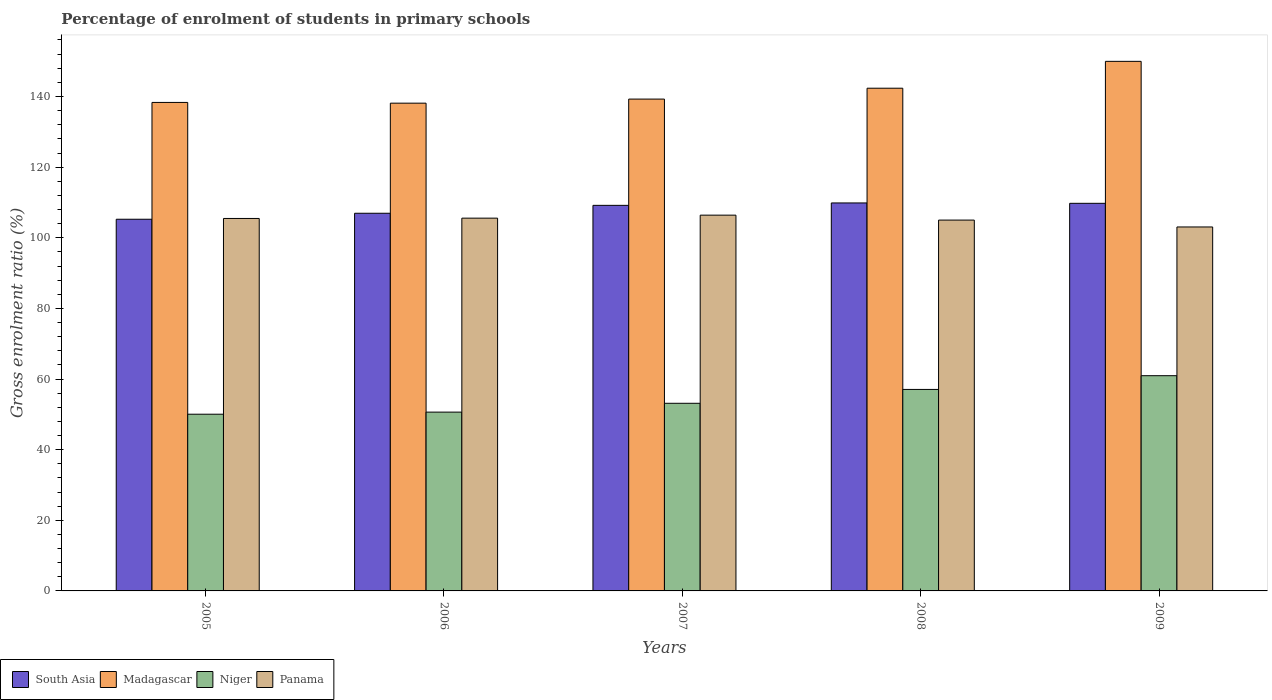How many different coloured bars are there?
Keep it short and to the point. 4. How many groups of bars are there?
Make the answer very short. 5. Are the number of bars per tick equal to the number of legend labels?
Offer a terse response. Yes. How many bars are there on the 5th tick from the left?
Offer a very short reply. 4. How many bars are there on the 2nd tick from the right?
Provide a short and direct response. 4. What is the label of the 2nd group of bars from the left?
Your response must be concise. 2006. In how many cases, is the number of bars for a given year not equal to the number of legend labels?
Keep it short and to the point. 0. What is the percentage of students enrolled in primary schools in Madagascar in 2005?
Provide a short and direct response. 138.32. Across all years, what is the maximum percentage of students enrolled in primary schools in Niger?
Your answer should be very brief. 60.94. Across all years, what is the minimum percentage of students enrolled in primary schools in South Asia?
Your answer should be compact. 105.25. In which year was the percentage of students enrolled in primary schools in Panama maximum?
Offer a very short reply. 2007. In which year was the percentage of students enrolled in primary schools in Niger minimum?
Provide a succinct answer. 2005. What is the total percentage of students enrolled in primary schools in Niger in the graph?
Offer a terse response. 271.79. What is the difference between the percentage of students enrolled in primary schools in South Asia in 2006 and that in 2008?
Provide a short and direct response. -2.92. What is the difference between the percentage of students enrolled in primary schools in Niger in 2007 and the percentage of students enrolled in primary schools in Panama in 2009?
Your response must be concise. -49.93. What is the average percentage of students enrolled in primary schools in Panama per year?
Offer a very short reply. 105.1. In the year 2005, what is the difference between the percentage of students enrolled in primary schools in Niger and percentage of students enrolled in primary schools in Panama?
Give a very brief answer. -55.43. What is the ratio of the percentage of students enrolled in primary schools in Madagascar in 2006 to that in 2008?
Offer a very short reply. 0.97. What is the difference between the highest and the second highest percentage of students enrolled in primary schools in Madagascar?
Your answer should be very brief. 7.61. What is the difference between the highest and the lowest percentage of students enrolled in primary schools in South Asia?
Offer a terse response. 4.61. In how many years, is the percentage of students enrolled in primary schools in Madagascar greater than the average percentage of students enrolled in primary schools in Madagascar taken over all years?
Offer a terse response. 2. What does the 4th bar from the left in 2007 represents?
Your answer should be compact. Panama. What does the 1st bar from the right in 2005 represents?
Offer a very short reply. Panama. Is it the case that in every year, the sum of the percentage of students enrolled in primary schools in Niger and percentage of students enrolled in primary schools in South Asia is greater than the percentage of students enrolled in primary schools in Madagascar?
Offer a very short reply. Yes. How many bars are there?
Ensure brevity in your answer.  20. What is the difference between two consecutive major ticks on the Y-axis?
Your answer should be very brief. 20. Where does the legend appear in the graph?
Offer a very short reply. Bottom left. How are the legend labels stacked?
Your response must be concise. Horizontal. What is the title of the graph?
Provide a short and direct response. Percentage of enrolment of students in primary schools. What is the label or title of the Y-axis?
Offer a terse response. Gross enrolment ratio (%). What is the Gross enrolment ratio (%) in South Asia in 2005?
Ensure brevity in your answer.  105.25. What is the Gross enrolment ratio (%) in Madagascar in 2005?
Provide a short and direct response. 138.32. What is the Gross enrolment ratio (%) of Niger in 2005?
Make the answer very short. 50.04. What is the Gross enrolment ratio (%) of Panama in 2005?
Your answer should be compact. 105.47. What is the Gross enrolment ratio (%) of South Asia in 2006?
Your answer should be compact. 106.94. What is the Gross enrolment ratio (%) in Madagascar in 2006?
Your response must be concise. 138.11. What is the Gross enrolment ratio (%) in Niger in 2006?
Offer a very short reply. 50.63. What is the Gross enrolment ratio (%) of Panama in 2006?
Your response must be concise. 105.55. What is the Gross enrolment ratio (%) in South Asia in 2007?
Give a very brief answer. 109.18. What is the Gross enrolment ratio (%) of Madagascar in 2007?
Provide a short and direct response. 139.27. What is the Gross enrolment ratio (%) in Niger in 2007?
Give a very brief answer. 53.13. What is the Gross enrolment ratio (%) in Panama in 2007?
Keep it short and to the point. 106.4. What is the Gross enrolment ratio (%) of South Asia in 2008?
Provide a succinct answer. 109.86. What is the Gross enrolment ratio (%) in Madagascar in 2008?
Keep it short and to the point. 142.35. What is the Gross enrolment ratio (%) of Niger in 2008?
Ensure brevity in your answer.  57.05. What is the Gross enrolment ratio (%) of Panama in 2008?
Ensure brevity in your answer.  105.01. What is the Gross enrolment ratio (%) in South Asia in 2009?
Your answer should be very brief. 109.75. What is the Gross enrolment ratio (%) in Madagascar in 2009?
Your answer should be very brief. 149.95. What is the Gross enrolment ratio (%) of Niger in 2009?
Offer a terse response. 60.94. What is the Gross enrolment ratio (%) in Panama in 2009?
Your answer should be compact. 103.06. Across all years, what is the maximum Gross enrolment ratio (%) of South Asia?
Your answer should be very brief. 109.86. Across all years, what is the maximum Gross enrolment ratio (%) in Madagascar?
Provide a succinct answer. 149.95. Across all years, what is the maximum Gross enrolment ratio (%) in Niger?
Your answer should be compact. 60.94. Across all years, what is the maximum Gross enrolment ratio (%) of Panama?
Your response must be concise. 106.4. Across all years, what is the minimum Gross enrolment ratio (%) of South Asia?
Your answer should be compact. 105.25. Across all years, what is the minimum Gross enrolment ratio (%) in Madagascar?
Offer a very short reply. 138.11. Across all years, what is the minimum Gross enrolment ratio (%) of Niger?
Your answer should be very brief. 50.04. Across all years, what is the minimum Gross enrolment ratio (%) of Panama?
Provide a short and direct response. 103.06. What is the total Gross enrolment ratio (%) in South Asia in the graph?
Ensure brevity in your answer.  540.97. What is the total Gross enrolment ratio (%) of Madagascar in the graph?
Ensure brevity in your answer.  708. What is the total Gross enrolment ratio (%) in Niger in the graph?
Your answer should be very brief. 271.79. What is the total Gross enrolment ratio (%) in Panama in the graph?
Your answer should be very brief. 525.48. What is the difference between the Gross enrolment ratio (%) in South Asia in 2005 and that in 2006?
Your answer should be compact. -1.69. What is the difference between the Gross enrolment ratio (%) of Madagascar in 2005 and that in 2006?
Your answer should be compact. 0.21. What is the difference between the Gross enrolment ratio (%) in Niger in 2005 and that in 2006?
Provide a short and direct response. -0.59. What is the difference between the Gross enrolment ratio (%) in Panama in 2005 and that in 2006?
Your answer should be compact. -0.09. What is the difference between the Gross enrolment ratio (%) of South Asia in 2005 and that in 2007?
Ensure brevity in your answer.  -3.93. What is the difference between the Gross enrolment ratio (%) of Madagascar in 2005 and that in 2007?
Your answer should be very brief. -0.95. What is the difference between the Gross enrolment ratio (%) of Niger in 2005 and that in 2007?
Make the answer very short. -3.09. What is the difference between the Gross enrolment ratio (%) in Panama in 2005 and that in 2007?
Keep it short and to the point. -0.94. What is the difference between the Gross enrolment ratio (%) in South Asia in 2005 and that in 2008?
Offer a terse response. -4.61. What is the difference between the Gross enrolment ratio (%) in Madagascar in 2005 and that in 2008?
Keep it short and to the point. -4.02. What is the difference between the Gross enrolment ratio (%) in Niger in 2005 and that in 2008?
Your response must be concise. -7.01. What is the difference between the Gross enrolment ratio (%) in Panama in 2005 and that in 2008?
Keep it short and to the point. 0.46. What is the difference between the Gross enrolment ratio (%) in South Asia in 2005 and that in 2009?
Your answer should be very brief. -4.51. What is the difference between the Gross enrolment ratio (%) in Madagascar in 2005 and that in 2009?
Keep it short and to the point. -11.63. What is the difference between the Gross enrolment ratio (%) of Niger in 2005 and that in 2009?
Give a very brief answer. -10.9. What is the difference between the Gross enrolment ratio (%) in Panama in 2005 and that in 2009?
Your answer should be very brief. 2.41. What is the difference between the Gross enrolment ratio (%) of South Asia in 2006 and that in 2007?
Give a very brief answer. -2.24. What is the difference between the Gross enrolment ratio (%) of Madagascar in 2006 and that in 2007?
Provide a succinct answer. -1.16. What is the difference between the Gross enrolment ratio (%) of Niger in 2006 and that in 2007?
Offer a very short reply. -2.5. What is the difference between the Gross enrolment ratio (%) of Panama in 2006 and that in 2007?
Your response must be concise. -0.85. What is the difference between the Gross enrolment ratio (%) in South Asia in 2006 and that in 2008?
Your answer should be compact. -2.92. What is the difference between the Gross enrolment ratio (%) in Madagascar in 2006 and that in 2008?
Keep it short and to the point. -4.23. What is the difference between the Gross enrolment ratio (%) in Niger in 2006 and that in 2008?
Ensure brevity in your answer.  -6.42. What is the difference between the Gross enrolment ratio (%) of Panama in 2006 and that in 2008?
Provide a succinct answer. 0.55. What is the difference between the Gross enrolment ratio (%) in South Asia in 2006 and that in 2009?
Offer a very short reply. -2.82. What is the difference between the Gross enrolment ratio (%) of Madagascar in 2006 and that in 2009?
Provide a succinct answer. -11.84. What is the difference between the Gross enrolment ratio (%) of Niger in 2006 and that in 2009?
Provide a succinct answer. -10.31. What is the difference between the Gross enrolment ratio (%) in Panama in 2006 and that in 2009?
Make the answer very short. 2.49. What is the difference between the Gross enrolment ratio (%) in South Asia in 2007 and that in 2008?
Your response must be concise. -0.68. What is the difference between the Gross enrolment ratio (%) in Madagascar in 2007 and that in 2008?
Make the answer very short. -3.08. What is the difference between the Gross enrolment ratio (%) of Niger in 2007 and that in 2008?
Ensure brevity in your answer.  -3.92. What is the difference between the Gross enrolment ratio (%) of Panama in 2007 and that in 2008?
Keep it short and to the point. 1.4. What is the difference between the Gross enrolment ratio (%) of South Asia in 2007 and that in 2009?
Your answer should be compact. -0.57. What is the difference between the Gross enrolment ratio (%) of Madagascar in 2007 and that in 2009?
Provide a short and direct response. -10.68. What is the difference between the Gross enrolment ratio (%) of Niger in 2007 and that in 2009?
Give a very brief answer. -7.81. What is the difference between the Gross enrolment ratio (%) in Panama in 2007 and that in 2009?
Provide a short and direct response. 3.34. What is the difference between the Gross enrolment ratio (%) of South Asia in 2008 and that in 2009?
Keep it short and to the point. 0.1. What is the difference between the Gross enrolment ratio (%) of Madagascar in 2008 and that in 2009?
Your answer should be very brief. -7.61. What is the difference between the Gross enrolment ratio (%) in Niger in 2008 and that in 2009?
Your answer should be very brief. -3.89. What is the difference between the Gross enrolment ratio (%) in Panama in 2008 and that in 2009?
Offer a very short reply. 1.95. What is the difference between the Gross enrolment ratio (%) of South Asia in 2005 and the Gross enrolment ratio (%) of Madagascar in 2006?
Offer a terse response. -32.87. What is the difference between the Gross enrolment ratio (%) in South Asia in 2005 and the Gross enrolment ratio (%) in Niger in 2006?
Your answer should be compact. 54.62. What is the difference between the Gross enrolment ratio (%) in South Asia in 2005 and the Gross enrolment ratio (%) in Panama in 2006?
Your answer should be very brief. -0.31. What is the difference between the Gross enrolment ratio (%) in Madagascar in 2005 and the Gross enrolment ratio (%) in Niger in 2006?
Your answer should be compact. 87.69. What is the difference between the Gross enrolment ratio (%) in Madagascar in 2005 and the Gross enrolment ratio (%) in Panama in 2006?
Your response must be concise. 32.77. What is the difference between the Gross enrolment ratio (%) in Niger in 2005 and the Gross enrolment ratio (%) in Panama in 2006?
Your answer should be compact. -55.51. What is the difference between the Gross enrolment ratio (%) of South Asia in 2005 and the Gross enrolment ratio (%) of Madagascar in 2007?
Provide a short and direct response. -34.02. What is the difference between the Gross enrolment ratio (%) in South Asia in 2005 and the Gross enrolment ratio (%) in Niger in 2007?
Make the answer very short. 52.12. What is the difference between the Gross enrolment ratio (%) in South Asia in 2005 and the Gross enrolment ratio (%) in Panama in 2007?
Your response must be concise. -1.16. What is the difference between the Gross enrolment ratio (%) in Madagascar in 2005 and the Gross enrolment ratio (%) in Niger in 2007?
Provide a short and direct response. 85.19. What is the difference between the Gross enrolment ratio (%) of Madagascar in 2005 and the Gross enrolment ratio (%) of Panama in 2007?
Provide a short and direct response. 31.92. What is the difference between the Gross enrolment ratio (%) of Niger in 2005 and the Gross enrolment ratio (%) of Panama in 2007?
Keep it short and to the point. -56.36. What is the difference between the Gross enrolment ratio (%) in South Asia in 2005 and the Gross enrolment ratio (%) in Madagascar in 2008?
Your answer should be very brief. -37.1. What is the difference between the Gross enrolment ratio (%) of South Asia in 2005 and the Gross enrolment ratio (%) of Niger in 2008?
Your answer should be very brief. 48.19. What is the difference between the Gross enrolment ratio (%) in South Asia in 2005 and the Gross enrolment ratio (%) in Panama in 2008?
Your response must be concise. 0.24. What is the difference between the Gross enrolment ratio (%) of Madagascar in 2005 and the Gross enrolment ratio (%) of Niger in 2008?
Keep it short and to the point. 81.27. What is the difference between the Gross enrolment ratio (%) of Madagascar in 2005 and the Gross enrolment ratio (%) of Panama in 2008?
Provide a succinct answer. 33.32. What is the difference between the Gross enrolment ratio (%) in Niger in 2005 and the Gross enrolment ratio (%) in Panama in 2008?
Your response must be concise. -54.97. What is the difference between the Gross enrolment ratio (%) in South Asia in 2005 and the Gross enrolment ratio (%) in Madagascar in 2009?
Give a very brief answer. -44.71. What is the difference between the Gross enrolment ratio (%) of South Asia in 2005 and the Gross enrolment ratio (%) of Niger in 2009?
Provide a succinct answer. 44.3. What is the difference between the Gross enrolment ratio (%) in South Asia in 2005 and the Gross enrolment ratio (%) in Panama in 2009?
Offer a terse response. 2.19. What is the difference between the Gross enrolment ratio (%) in Madagascar in 2005 and the Gross enrolment ratio (%) in Niger in 2009?
Keep it short and to the point. 77.38. What is the difference between the Gross enrolment ratio (%) of Madagascar in 2005 and the Gross enrolment ratio (%) of Panama in 2009?
Your answer should be compact. 35.27. What is the difference between the Gross enrolment ratio (%) in Niger in 2005 and the Gross enrolment ratio (%) in Panama in 2009?
Offer a very short reply. -53.02. What is the difference between the Gross enrolment ratio (%) in South Asia in 2006 and the Gross enrolment ratio (%) in Madagascar in 2007?
Your answer should be very brief. -32.33. What is the difference between the Gross enrolment ratio (%) of South Asia in 2006 and the Gross enrolment ratio (%) of Niger in 2007?
Give a very brief answer. 53.81. What is the difference between the Gross enrolment ratio (%) in South Asia in 2006 and the Gross enrolment ratio (%) in Panama in 2007?
Offer a very short reply. 0.54. What is the difference between the Gross enrolment ratio (%) in Madagascar in 2006 and the Gross enrolment ratio (%) in Niger in 2007?
Provide a short and direct response. 84.98. What is the difference between the Gross enrolment ratio (%) in Madagascar in 2006 and the Gross enrolment ratio (%) in Panama in 2007?
Offer a very short reply. 31.71. What is the difference between the Gross enrolment ratio (%) in Niger in 2006 and the Gross enrolment ratio (%) in Panama in 2007?
Make the answer very short. -55.77. What is the difference between the Gross enrolment ratio (%) in South Asia in 2006 and the Gross enrolment ratio (%) in Madagascar in 2008?
Your answer should be compact. -35.41. What is the difference between the Gross enrolment ratio (%) in South Asia in 2006 and the Gross enrolment ratio (%) in Niger in 2008?
Keep it short and to the point. 49.89. What is the difference between the Gross enrolment ratio (%) of South Asia in 2006 and the Gross enrolment ratio (%) of Panama in 2008?
Your answer should be very brief. 1.93. What is the difference between the Gross enrolment ratio (%) in Madagascar in 2006 and the Gross enrolment ratio (%) in Niger in 2008?
Provide a succinct answer. 81.06. What is the difference between the Gross enrolment ratio (%) in Madagascar in 2006 and the Gross enrolment ratio (%) in Panama in 2008?
Your answer should be very brief. 33.11. What is the difference between the Gross enrolment ratio (%) of Niger in 2006 and the Gross enrolment ratio (%) of Panama in 2008?
Offer a very short reply. -54.38. What is the difference between the Gross enrolment ratio (%) of South Asia in 2006 and the Gross enrolment ratio (%) of Madagascar in 2009?
Offer a very short reply. -43.01. What is the difference between the Gross enrolment ratio (%) in South Asia in 2006 and the Gross enrolment ratio (%) in Niger in 2009?
Offer a very short reply. 46. What is the difference between the Gross enrolment ratio (%) of South Asia in 2006 and the Gross enrolment ratio (%) of Panama in 2009?
Your answer should be very brief. 3.88. What is the difference between the Gross enrolment ratio (%) of Madagascar in 2006 and the Gross enrolment ratio (%) of Niger in 2009?
Your answer should be very brief. 77.17. What is the difference between the Gross enrolment ratio (%) in Madagascar in 2006 and the Gross enrolment ratio (%) in Panama in 2009?
Provide a succinct answer. 35.05. What is the difference between the Gross enrolment ratio (%) of Niger in 2006 and the Gross enrolment ratio (%) of Panama in 2009?
Give a very brief answer. -52.43. What is the difference between the Gross enrolment ratio (%) of South Asia in 2007 and the Gross enrolment ratio (%) of Madagascar in 2008?
Keep it short and to the point. -33.17. What is the difference between the Gross enrolment ratio (%) in South Asia in 2007 and the Gross enrolment ratio (%) in Niger in 2008?
Provide a short and direct response. 52.13. What is the difference between the Gross enrolment ratio (%) in South Asia in 2007 and the Gross enrolment ratio (%) in Panama in 2008?
Keep it short and to the point. 4.17. What is the difference between the Gross enrolment ratio (%) of Madagascar in 2007 and the Gross enrolment ratio (%) of Niger in 2008?
Ensure brevity in your answer.  82.22. What is the difference between the Gross enrolment ratio (%) of Madagascar in 2007 and the Gross enrolment ratio (%) of Panama in 2008?
Provide a succinct answer. 34.26. What is the difference between the Gross enrolment ratio (%) in Niger in 2007 and the Gross enrolment ratio (%) in Panama in 2008?
Provide a succinct answer. -51.88. What is the difference between the Gross enrolment ratio (%) of South Asia in 2007 and the Gross enrolment ratio (%) of Madagascar in 2009?
Offer a terse response. -40.77. What is the difference between the Gross enrolment ratio (%) in South Asia in 2007 and the Gross enrolment ratio (%) in Niger in 2009?
Provide a short and direct response. 48.24. What is the difference between the Gross enrolment ratio (%) of South Asia in 2007 and the Gross enrolment ratio (%) of Panama in 2009?
Your response must be concise. 6.12. What is the difference between the Gross enrolment ratio (%) of Madagascar in 2007 and the Gross enrolment ratio (%) of Niger in 2009?
Keep it short and to the point. 78.33. What is the difference between the Gross enrolment ratio (%) of Madagascar in 2007 and the Gross enrolment ratio (%) of Panama in 2009?
Keep it short and to the point. 36.21. What is the difference between the Gross enrolment ratio (%) of Niger in 2007 and the Gross enrolment ratio (%) of Panama in 2009?
Give a very brief answer. -49.93. What is the difference between the Gross enrolment ratio (%) of South Asia in 2008 and the Gross enrolment ratio (%) of Madagascar in 2009?
Give a very brief answer. -40.09. What is the difference between the Gross enrolment ratio (%) in South Asia in 2008 and the Gross enrolment ratio (%) in Niger in 2009?
Offer a terse response. 48.92. What is the difference between the Gross enrolment ratio (%) in South Asia in 2008 and the Gross enrolment ratio (%) in Panama in 2009?
Offer a very short reply. 6.8. What is the difference between the Gross enrolment ratio (%) of Madagascar in 2008 and the Gross enrolment ratio (%) of Niger in 2009?
Give a very brief answer. 81.4. What is the difference between the Gross enrolment ratio (%) in Madagascar in 2008 and the Gross enrolment ratio (%) in Panama in 2009?
Your answer should be compact. 39.29. What is the difference between the Gross enrolment ratio (%) in Niger in 2008 and the Gross enrolment ratio (%) in Panama in 2009?
Give a very brief answer. -46. What is the average Gross enrolment ratio (%) of South Asia per year?
Your answer should be very brief. 108.19. What is the average Gross enrolment ratio (%) in Madagascar per year?
Offer a terse response. 141.6. What is the average Gross enrolment ratio (%) in Niger per year?
Give a very brief answer. 54.36. What is the average Gross enrolment ratio (%) in Panama per year?
Your answer should be compact. 105.1. In the year 2005, what is the difference between the Gross enrolment ratio (%) in South Asia and Gross enrolment ratio (%) in Madagascar?
Ensure brevity in your answer.  -33.08. In the year 2005, what is the difference between the Gross enrolment ratio (%) in South Asia and Gross enrolment ratio (%) in Niger?
Keep it short and to the point. 55.21. In the year 2005, what is the difference between the Gross enrolment ratio (%) of South Asia and Gross enrolment ratio (%) of Panama?
Provide a short and direct response. -0.22. In the year 2005, what is the difference between the Gross enrolment ratio (%) in Madagascar and Gross enrolment ratio (%) in Niger?
Provide a succinct answer. 88.28. In the year 2005, what is the difference between the Gross enrolment ratio (%) in Madagascar and Gross enrolment ratio (%) in Panama?
Offer a very short reply. 32.86. In the year 2005, what is the difference between the Gross enrolment ratio (%) in Niger and Gross enrolment ratio (%) in Panama?
Your response must be concise. -55.43. In the year 2006, what is the difference between the Gross enrolment ratio (%) in South Asia and Gross enrolment ratio (%) in Madagascar?
Ensure brevity in your answer.  -31.17. In the year 2006, what is the difference between the Gross enrolment ratio (%) of South Asia and Gross enrolment ratio (%) of Niger?
Give a very brief answer. 56.31. In the year 2006, what is the difference between the Gross enrolment ratio (%) of South Asia and Gross enrolment ratio (%) of Panama?
Keep it short and to the point. 1.39. In the year 2006, what is the difference between the Gross enrolment ratio (%) in Madagascar and Gross enrolment ratio (%) in Niger?
Ensure brevity in your answer.  87.48. In the year 2006, what is the difference between the Gross enrolment ratio (%) in Madagascar and Gross enrolment ratio (%) in Panama?
Offer a terse response. 32.56. In the year 2006, what is the difference between the Gross enrolment ratio (%) in Niger and Gross enrolment ratio (%) in Panama?
Your response must be concise. -54.92. In the year 2007, what is the difference between the Gross enrolment ratio (%) in South Asia and Gross enrolment ratio (%) in Madagascar?
Provide a short and direct response. -30.09. In the year 2007, what is the difference between the Gross enrolment ratio (%) in South Asia and Gross enrolment ratio (%) in Niger?
Offer a terse response. 56.05. In the year 2007, what is the difference between the Gross enrolment ratio (%) of South Asia and Gross enrolment ratio (%) of Panama?
Your answer should be compact. 2.78. In the year 2007, what is the difference between the Gross enrolment ratio (%) in Madagascar and Gross enrolment ratio (%) in Niger?
Offer a terse response. 86.14. In the year 2007, what is the difference between the Gross enrolment ratio (%) in Madagascar and Gross enrolment ratio (%) in Panama?
Offer a very short reply. 32.87. In the year 2007, what is the difference between the Gross enrolment ratio (%) of Niger and Gross enrolment ratio (%) of Panama?
Offer a terse response. -53.27. In the year 2008, what is the difference between the Gross enrolment ratio (%) in South Asia and Gross enrolment ratio (%) in Madagascar?
Make the answer very short. -32.49. In the year 2008, what is the difference between the Gross enrolment ratio (%) in South Asia and Gross enrolment ratio (%) in Niger?
Provide a succinct answer. 52.81. In the year 2008, what is the difference between the Gross enrolment ratio (%) of South Asia and Gross enrolment ratio (%) of Panama?
Offer a very short reply. 4.85. In the year 2008, what is the difference between the Gross enrolment ratio (%) of Madagascar and Gross enrolment ratio (%) of Niger?
Your answer should be very brief. 85.29. In the year 2008, what is the difference between the Gross enrolment ratio (%) in Madagascar and Gross enrolment ratio (%) in Panama?
Your answer should be very brief. 37.34. In the year 2008, what is the difference between the Gross enrolment ratio (%) in Niger and Gross enrolment ratio (%) in Panama?
Ensure brevity in your answer.  -47.95. In the year 2009, what is the difference between the Gross enrolment ratio (%) of South Asia and Gross enrolment ratio (%) of Madagascar?
Make the answer very short. -40.2. In the year 2009, what is the difference between the Gross enrolment ratio (%) in South Asia and Gross enrolment ratio (%) in Niger?
Make the answer very short. 48.81. In the year 2009, what is the difference between the Gross enrolment ratio (%) of South Asia and Gross enrolment ratio (%) of Panama?
Offer a very short reply. 6.7. In the year 2009, what is the difference between the Gross enrolment ratio (%) of Madagascar and Gross enrolment ratio (%) of Niger?
Make the answer very short. 89.01. In the year 2009, what is the difference between the Gross enrolment ratio (%) in Madagascar and Gross enrolment ratio (%) in Panama?
Make the answer very short. 46.89. In the year 2009, what is the difference between the Gross enrolment ratio (%) of Niger and Gross enrolment ratio (%) of Panama?
Make the answer very short. -42.12. What is the ratio of the Gross enrolment ratio (%) of South Asia in 2005 to that in 2006?
Offer a terse response. 0.98. What is the ratio of the Gross enrolment ratio (%) in Madagascar in 2005 to that in 2006?
Make the answer very short. 1. What is the ratio of the Gross enrolment ratio (%) of Niger in 2005 to that in 2006?
Ensure brevity in your answer.  0.99. What is the ratio of the Gross enrolment ratio (%) of Panama in 2005 to that in 2006?
Offer a very short reply. 1. What is the ratio of the Gross enrolment ratio (%) of Madagascar in 2005 to that in 2007?
Offer a terse response. 0.99. What is the ratio of the Gross enrolment ratio (%) of Niger in 2005 to that in 2007?
Offer a terse response. 0.94. What is the ratio of the Gross enrolment ratio (%) in Panama in 2005 to that in 2007?
Give a very brief answer. 0.99. What is the ratio of the Gross enrolment ratio (%) of South Asia in 2005 to that in 2008?
Your response must be concise. 0.96. What is the ratio of the Gross enrolment ratio (%) in Madagascar in 2005 to that in 2008?
Offer a terse response. 0.97. What is the ratio of the Gross enrolment ratio (%) of Niger in 2005 to that in 2008?
Keep it short and to the point. 0.88. What is the ratio of the Gross enrolment ratio (%) of Panama in 2005 to that in 2008?
Your answer should be very brief. 1. What is the ratio of the Gross enrolment ratio (%) in South Asia in 2005 to that in 2009?
Your response must be concise. 0.96. What is the ratio of the Gross enrolment ratio (%) of Madagascar in 2005 to that in 2009?
Keep it short and to the point. 0.92. What is the ratio of the Gross enrolment ratio (%) of Niger in 2005 to that in 2009?
Provide a short and direct response. 0.82. What is the ratio of the Gross enrolment ratio (%) of Panama in 2005 to that in 2009?
Make the answer very short. 1.02. What is the ratio of the Gross enrolment ratio (%) in South Asia in 2006 to that in 2007?
Provide a succinct answer. 0.98. What is the ratio of the Gross enrolment ratio (%) of Niger in 2006 to that in 2007?
Provide a short and direct response. 0.95. What is the ratio of the Gross enrolment ratio (%) of South Asia in 2006 to that in 2008?
Ensure brevity in your answer.  0.97. What is the ratio of the Gross enrolment ratio (%) of Madagascar in 2006 to that in 2008?
Provide a short and direct response. 0.97. What is the ratio of the Gross enrolment ratio (%) of Niger in 2006 to that in 2008?
Offer a terse response. 0.89. What is the ratio of the Gross enrolment ratio (%) of Panama in 2006 to that in 2008?
Offer a very short reply. 1.01. What is the ratio of the Gross enrolment ratio (%) in South Asia in 2006 to that in 2009?
Ensure brevity in your answer.  0.97. What is the ratio of the Gross enrolment ratio (%) in Madagascar in 2006 to that in 2009?
Make the answer very short. 0.92. What is the ratio of the Gross enrolment ratio (%) of Niger in 2006 to that in 2009?
Keep it short and to the point. 0.83. What is the ratio of the Gross enrolment ratio (%) in Panama in 2006 to that in 2009?
Ensure brevity in your answer.  1.02. What is the ratio of the Gross enrolment ratio (%) in Madagascar in 2007 to that in 2008?
Ensure brevity in your answer.  0.98. What is the ratio of the Gross enrolment ratio (%) of Niger in 2007 to that in 2008?
Your answer should be compact. 0.93. What is the ratio of the Gross enrolment ratio (%) of Panama in 2007 to that in 2008?
Offer a very short reply. 1.01. What is the ratio of the Gross enrolment ratio (%) of South Asia in 2007 to that in 2009?
Offer a terse response. 0.99. What is the ratio of the Gross enrolment ratio (%) of Madagascar in 2007 to that in 2009?
Keep it short and to the point. 0.93. What is the ratio of the Gross enrolment ratio (%) of Niger in 2007 to that in 2009?
Provide a succinct answer. 0.87. What is the ratio of the Gross enrolment ratio (%) in Panama in 2007 to that in 2009?
Ensure brevity in your answer.  1.03. What is the ratio of the Gross enrolment ratio (%) of Madagascar in 2008 to that in 2009?
Keep it short and to the point. 0.95. What is the ratio of the Gross enrolment ratio (%) in Niger in 2008 to that in 2009?
Offer a terse response. 0.94. What is the ratio of the Gross enrolment ratio (%) in Panama in 2008 to that in 2009?
Give a very brief answer. 1.02. What is the difference between the highest and the second highest Gross enrolment ratio (%) of South Asia?
Your answer should be compact. 0.1. What is the difference between the highest and the second highest Gross enrolment ratio (%) of Madagascar?
Offer a terse response. 7.61. What is the difference between the highest and the second highest Gross enrolment ratio (%) of Niger?
Your answer should be very brief. 3.89. What is the difference between the highest and the second highest Gross enrolment ratio (%) of Panama?
Ensure brevity in your answer.  0.85. What is the difference between the highest and the lowest Gross enrolment ratio (%) of South Asia?
Make the answer very short. 4.61. What is the difference between the highest and the lowest Gross enrolment ratio (%) of Madagascar?
Your answer should be very brief. 11.84. What is the difference between the highest and the lowest Gross enrolment ratio (%) of Niger?
Offer a very short reply. 10.9. What is the difference between the highest and the lowest Gross enrolment ratio (%) of Panama?
Keep it short and to the point. 3.34. 